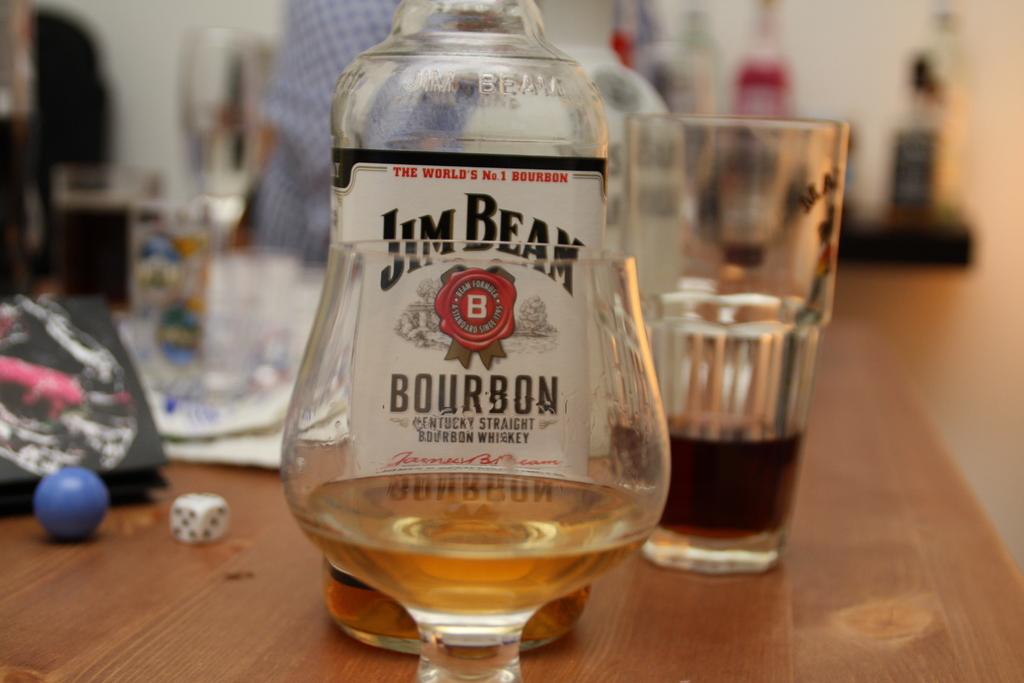Who makes this bourbon?
Keep it short and to the point. Jim beam. What type of liquor is this?
Offer a terse response. Bourbon. 